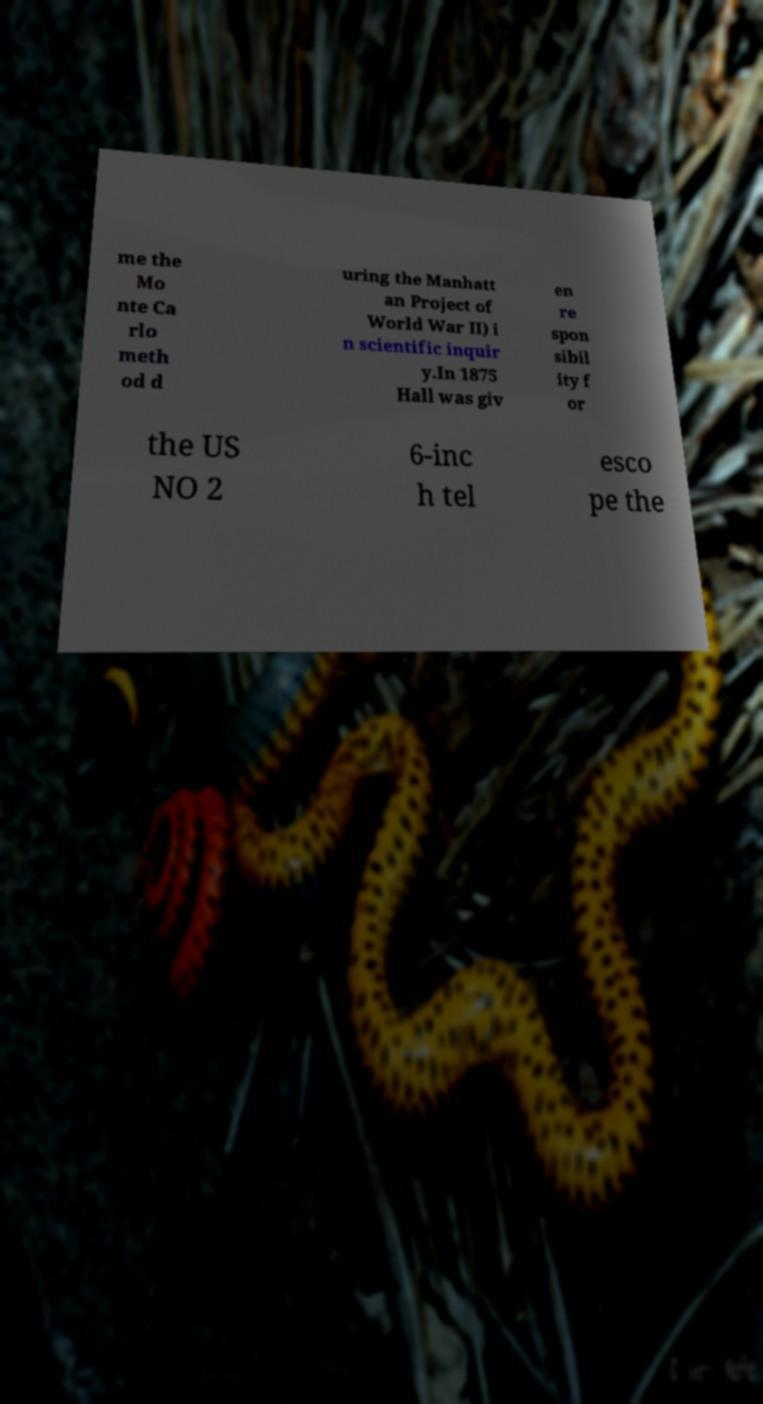Could you extract and type out the text from this image? me the Mo nte Ca rlo meth od d uring the Manhatt an Project of World War II) i n scientific inquir y.In 1875 Hall was giv en re spon sibil ity f or the US NO 2 6-inc h tel esco pe the 